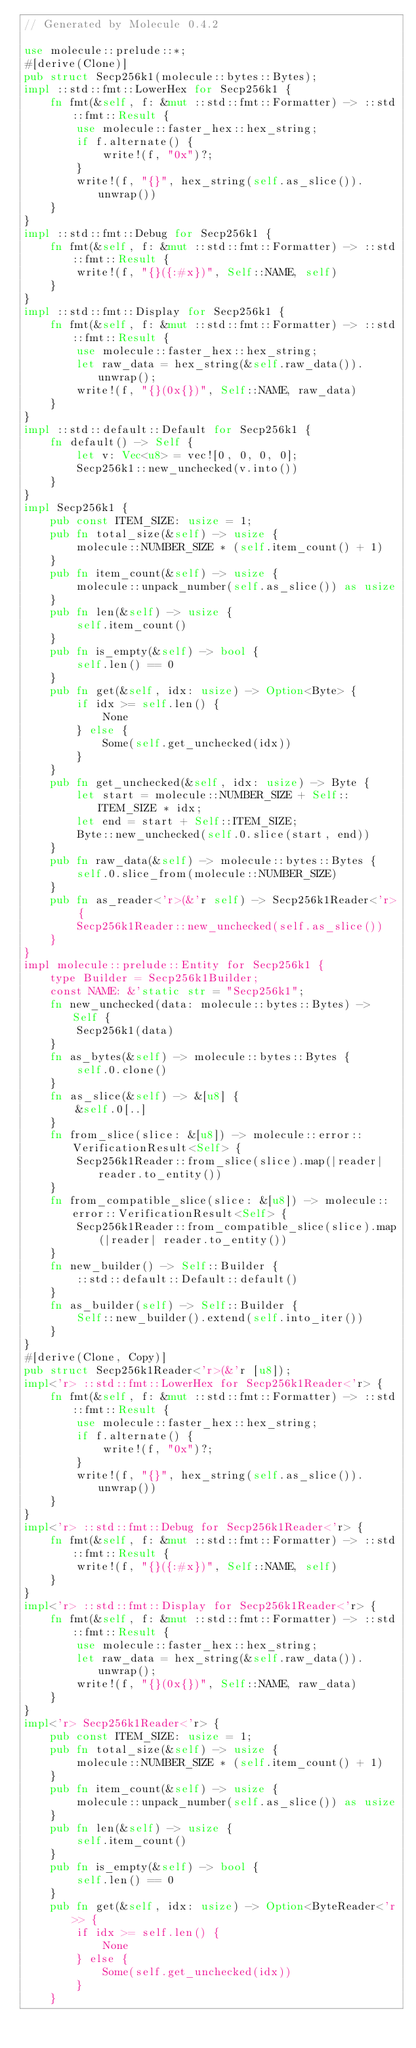Convert code to text. <code><loc_0><loc_0><loc_500><loc_500><_Rust_>// Generated by Molecule 0.4.2

use molecule::prelude::*;
#[derive(Clone)]
pub struct Secp256k1(molecule::bytes::Bytes);
impl ::std::fmt::LowerHex for Secp256k1 {
    fn fmt(&self, f: &mut ::std::fmt::Formatter) -> ::std::fmt::Result {
        use molecule::faster_hex::hex_string;
        if f.alternate() {
            write!(f, "0x")?;
        }
        write!(f, "{}", hex_string(self.as_slice()).unwrap())
    }
}
impl ::std::fmt::Debug for Secp256k1 {
    fn fmt(&self, f: &mut ::std::fmt::Formatter) -> ::std::fmt::Result {
        write!(f, "{}({:#x})", Self::NAME, self)
    }
}
impl ::std::fmt::Display for Secp256k1 {
    fn fmt(&self, f: &mut ::std::fmt::Formatter) -> ::std::fmt::Result {
        use molecule::faster_hex::hex_string;
        let raw_data = hex_string(&self.raw_data()).unwrap();
        write!(f, "{}(0x{})", Self::NAME, raw_data)
    }
}
impl ::std::default::Default for Secp256k1 {
    fn default() -> Self {
        let v: Vec<u8> = vec![0, 0, 0, 0];
        Secp256k1::new_unchecked(v.into())
    }
}
impl Secp256k1 {
    pub const ITEM_SIZE: usize = 1;
    pub fn total_size(&self) -> usize {
        molecule::NUMBER_SIZE * (self.item_count() + 1)
    }
    pub fn item_count(&self) -> usize {
        molecule::unpack_number(self.as_slice()) as usize
    }
    pub fn len(&self) -> usize {
        self.item_count()
    }
    pub fn is_empty(&self) -> bool {
        self.len() == 0
    }
    pub fn get(&self, idx: usize) -> Option<Byte> {
        if idx >= self.len() {
            None
        } else {
            Some(self.get_unchecked(idx))
        }
    }
    pub fn get_unchecked(&self, idx: usize) -> Byte {
        let start = molecule::NUMBER_SIZE + Self::ITEM_SIZE * idx;
        let end = start + Self::ITEM_SIZE;
        Byte::new_unchecked(self.0.slice(start, end))
    }
    pub fn raw_data(&self) -> molecule::bytes::Bytes {
        self.0.slice_from(molecule::NUMBER_SIZE)
    }
    pub fn as_reader<'r>(&'r self) -> Secp256k1Reader<'r> {
        Secp256k1Reader::new_unchecked(self.as_slice())
    }
}
impl molecule::prelude::Entity for Secp256k1 {
    type Builder = Secp256k1Builder;
    const NAME: &'static str = "Secp256k1";
    fn new_unchecked(data: molecule::bytes::Bytes) -> Self {
        Secp256k1(data)
    }
    fn as_bytes(&self) -> molecule::bytes::Bytes {
        self.0.clone()
    }
    fn as_slice(&self) -> &[u8] {
        &self.0[..]
    }
    fn from_slice(slice: &[u8]) -> molecule::error::VerificationResult<Self> {
        Secp256k1Reader::from_slice(slice).map(|reader| reader.to_entity())
    }
    fn from_compatible_slice(slice: &[u8]) -> molecule::error::VerificationResult<Self> {
        Secp256k1Reader::from_compatible_slice(slice).map(|reader| reader.to_entity())
    }
    fn new_builder() -> Self::Builder {
        ::std::default::Default::default()
    }
    fn as_builder(self) -> Self::Builder {
        Self::new_builder().extend(self.into_iter())
    }
}
#[derive(Clone, Copy)]
pub struct Secp256k1Reader<'r>(&'r [u8]);
impl<'r> ::std::fmt::LowerHex for Secp256k1Reader<'r> {
    fn fmt(&self, f: &mut ::std::fmt::Formatter) -> ::std::fmt::Result {
        use molecule::faster_hex::hex_string;
        if f.alternate() {
            write!(f, "0x")?;
        }
        write!(f, "{}", hex_string(self.as_slice()).unwrap())
    }
}
impl<'r> ::std::fmt::Debug for Secp256k1Reader<'r> {
    fn fmt(&self, f: &mut ::std::fmt::Formatter) -> ::std::fmt::Result {
        write!(f, "{}({:#x})", Self::NAME, self)
    }
}
impl<'r> ::std::fmt::Display for Secp256k1Reader<'r> {
    fn fmt(&self, f: &mut ::std::fmt::Formatter) -> ::std::fmt::Result {
        use molecule::faster_hex::hex_string;
        let raw_data = hex_string(&self.raw_data()).unwrap();
        write!(f, "{}(0x{})", Self::NAME, raw_data)
    }
}
impl<'r> Secp256k1Reader<'r> {
    pub const ITEM_SIZE: usize = 1;
    pub fn total_size(&self) -> usize {
        molecule::NUMBER_SIZE * (self.item_count() + 1)
    }
    pub fn item_count(&self) -> usize {
        molecule::unpack_number(self.as_slice()) as usize
    }
    pub fn len(&self) -> usize {
        self.item_count()
    }
    pub fn is_empty(&self) -> bool {
        self.len() == 0
    }
    pub fn get(&self, idx: usize) -> Option<ByteReader<'r>> {
        if idx >= self.len() {
            None
        } else {
            Some(self.get_unchecked(idx))
        }
    }</code> 